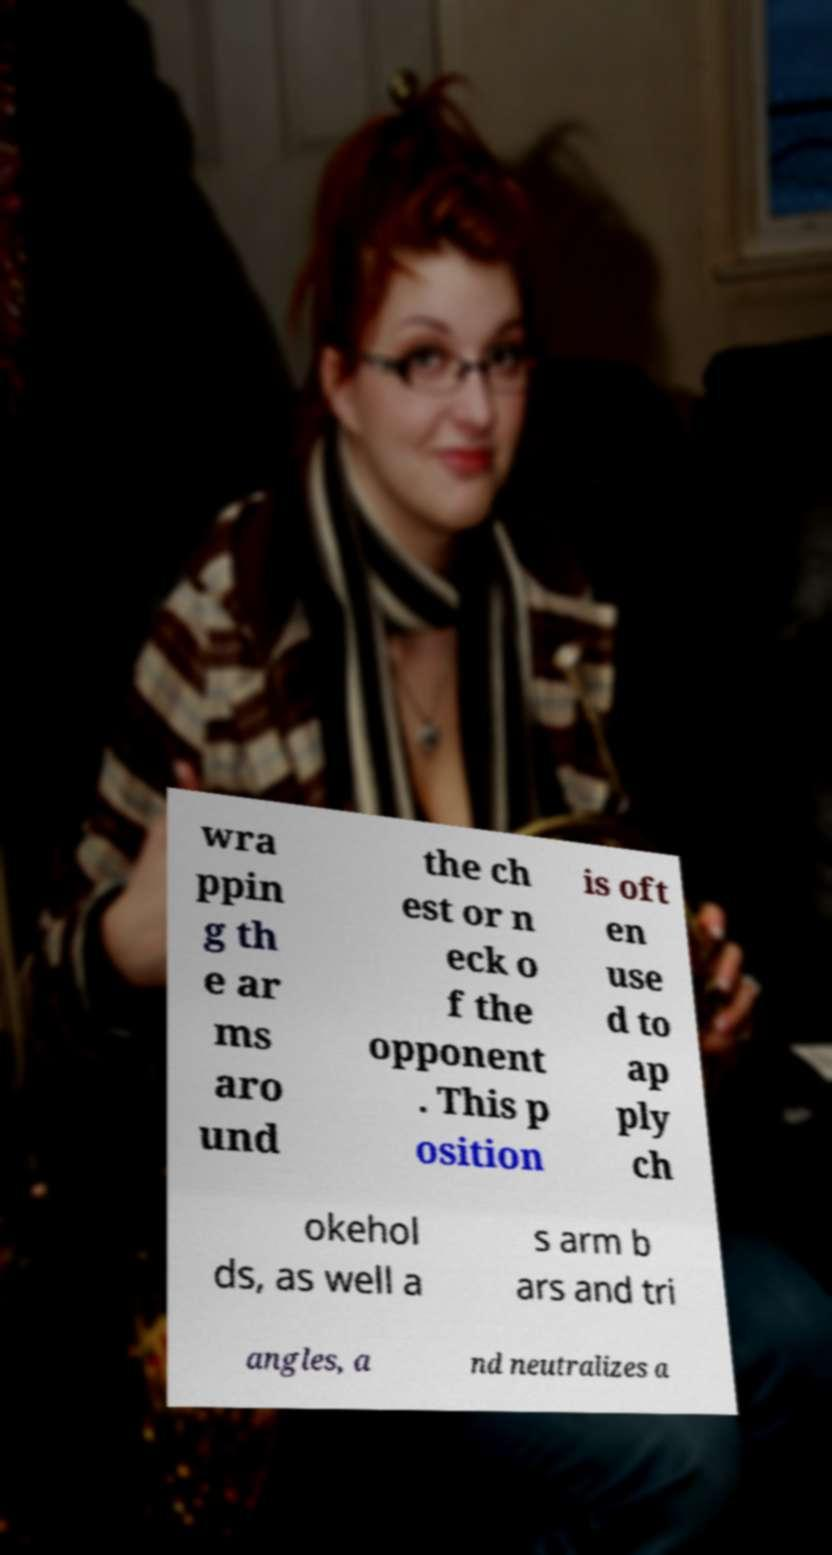Can you accurately transcribe the text from the provided image for me? wra ppin g th e ar ms aro und the ch est or n eck o f the opponent . This p osition is oft en use d to ap ply ch okehol ds, as well a s arm b ars and tri angles, a nd neutralizes a 